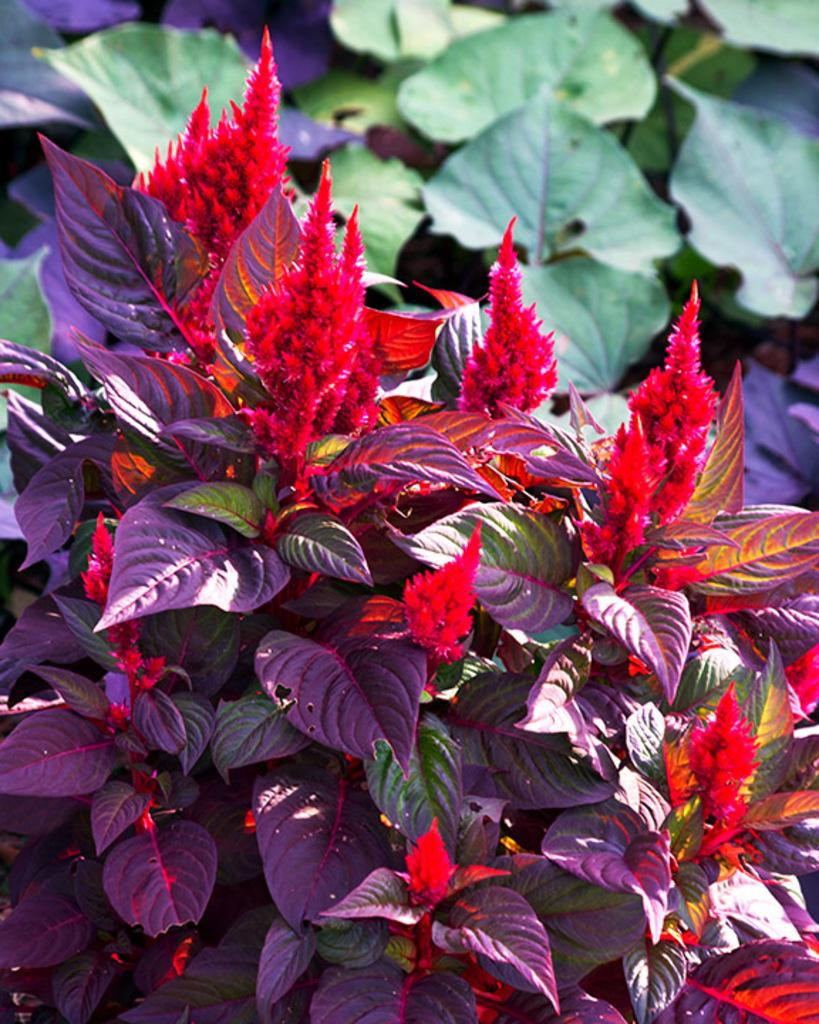What type of living organisms can be seen in the image? Plants can be seen in the image. What are the plants displaying? There are flowers on the plants. What is the moon doing in the image? The moon is not present in the image; it only features plants with flowers. 